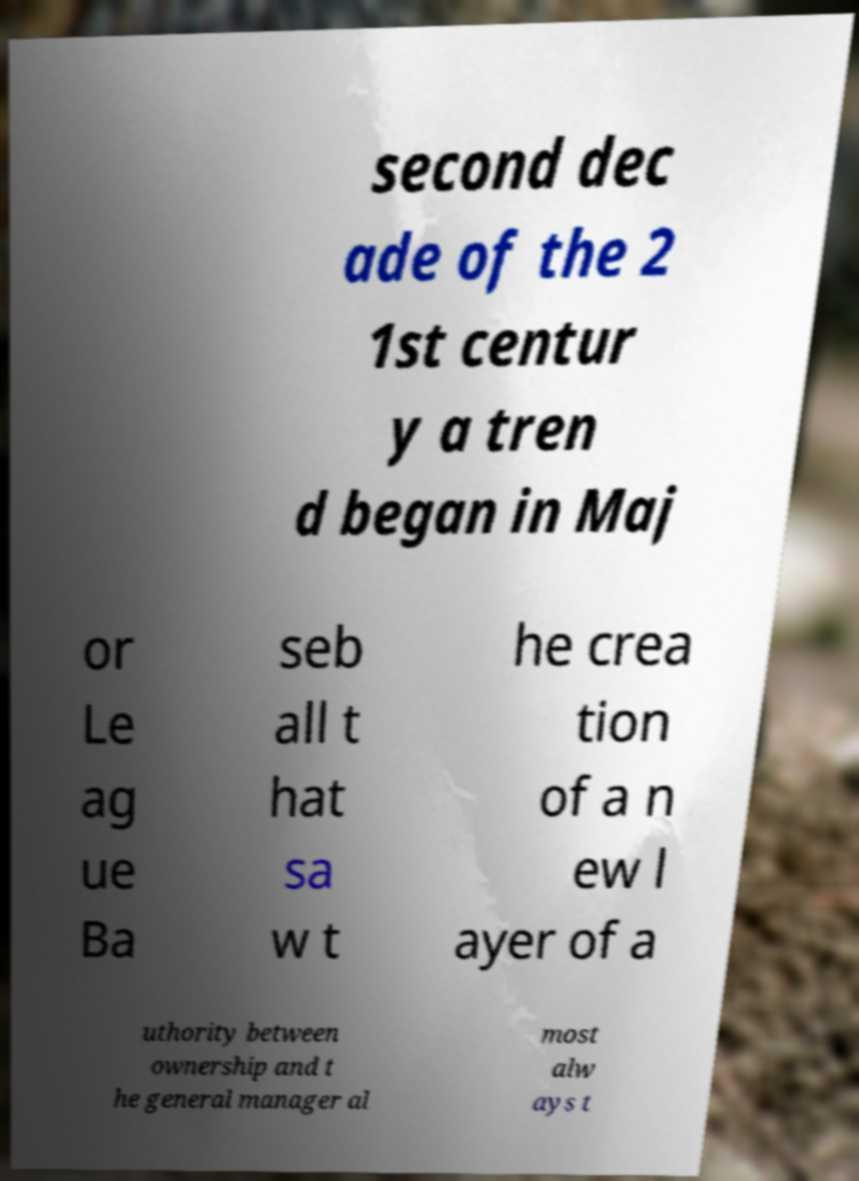There's text embedded in this image that I need extracted. Can you transcribe it verbatim? second dec ade of the 2 1st centur y a tren d began in Maj or Le ag ue Ba seb all t hat sa w t he crea tion of a n ew l ayer of a uthority between ownership and t he general manager al most alw ays t 